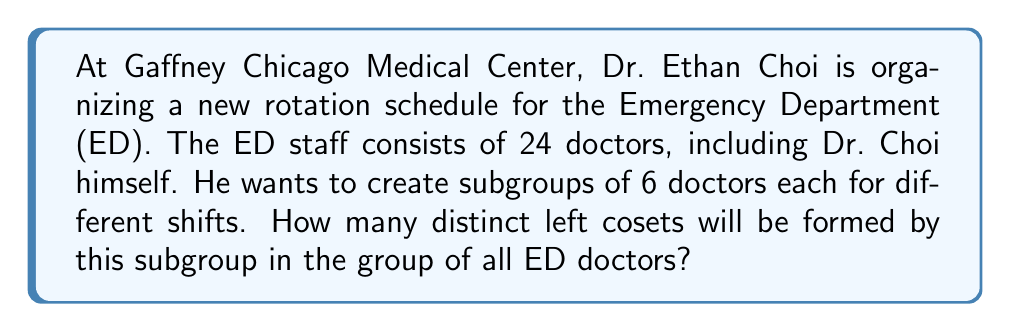Give your solution to this math problem. Let's approach this step-by-step using group theory concepts:

1) First, we need to identify our group and subgroup:
   - The group $G$ is the set of all ED doctors, with $|G| = 24$
   - The subgroup $H$ is a set of 6 doctors for a shift, so $|H| = 6$

2) Recall the formula for the number of distinct left cosets:
   $$ \text{Number of distinct left cosets} = [G:H] = \frac{|G|}{|H|} $$
   Where $[G:H]$ is the index of $H$ in $G$.

3) Substituting our values:
   $$ [G:H] = \frac{|G|}{|H|} = \frac{24}{6} $$

4) Simplify:
   $$ [G:H] = 4 $$

5) This result means that the group of all ED doctors can be partitioned into 4 distinct left cosets, each containing 6 doctors.

6) In the context of Dr. Choi's scheduling, this implies that he can create 4 distinct shifts, each with 6 doctors, covering all 24 ED doctors without overlap.
Answer: The number of distinct left cosets is 4. 